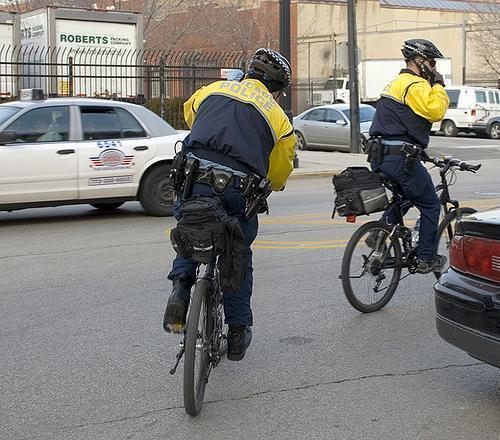What profession are the men on bikes?
Select the correct answer and articulate reasoning with the following format: 'Answer: answer
Rationale: rationale.'
Options: Lawyers, racers, dentists, police officers. Answer: police officers.
Rationale: By the name on their jackets and their utility belts, it's easy to tell who they are. 